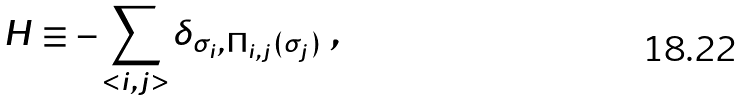Convert formula to latex. <formula><loc_0><loc_0><loc_500><loc_500>H \equiv - \sum _ { < i , j > } \delta _ { \sigma _ { i } , \Pi _ { i , j } ( \sigma _ { j } ) } \ ,</formula> 